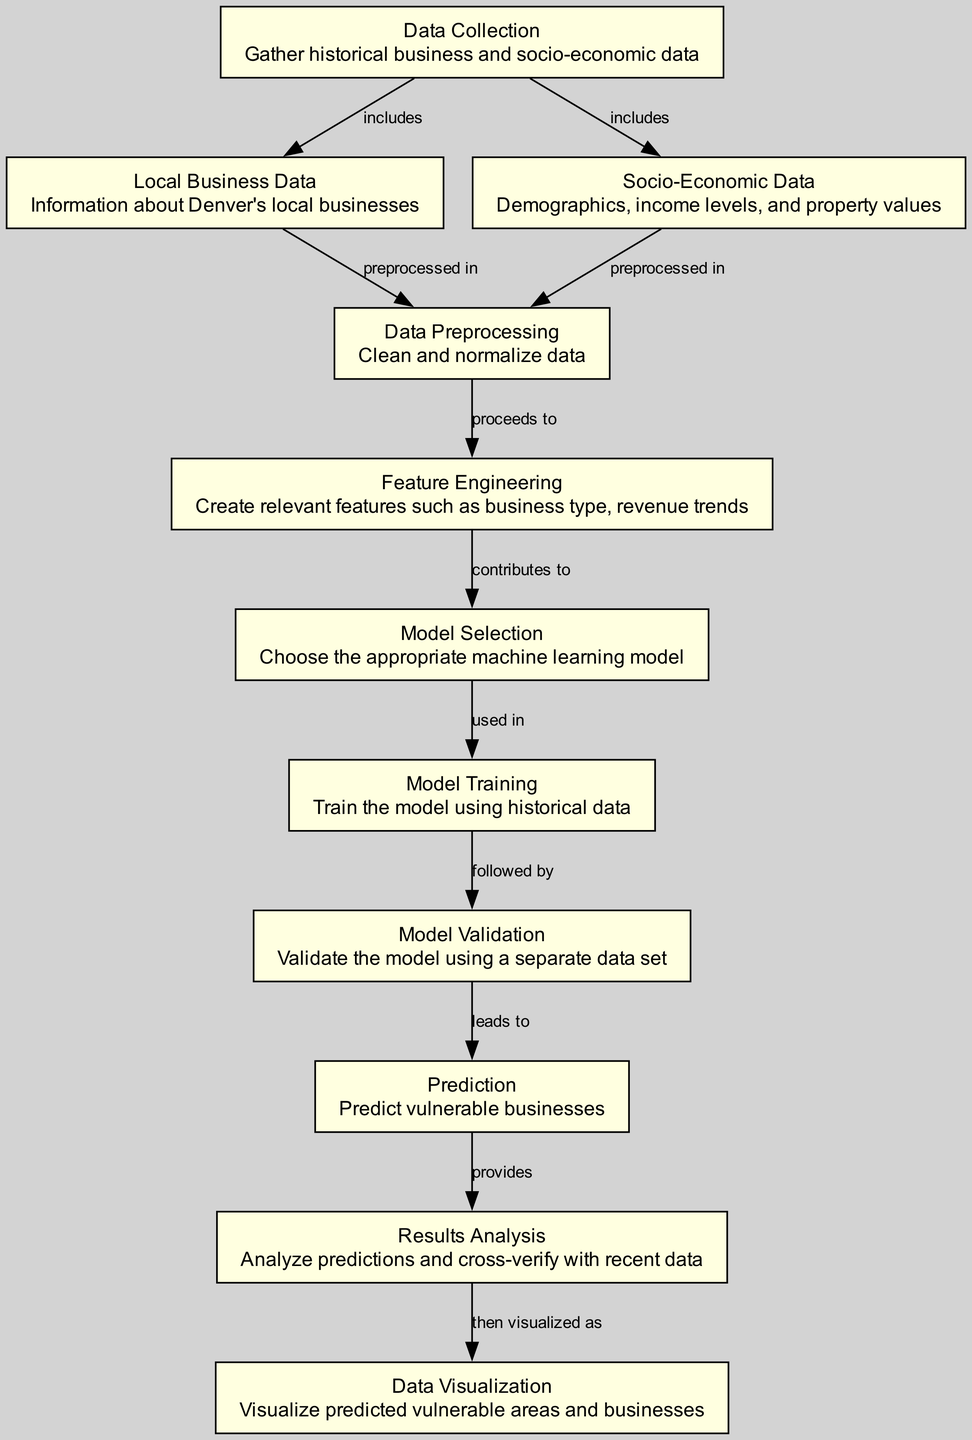What is the first step in the machine learning process? According to the diagram, the first step is "Data Collection," which involves gathering historical business and socio-economic data.
Answer: Data Collection How many nodes are present in the diagram? Counting the nodes listed in the diagram, there are eleven distinct nodes representing various steps in the machine learning process.
Answer: Eleven What type of data is included in data collection? The data collection includes "Local Business Data" and "Socio-Economic Data," reflecting the types of information gathered for analysis.
Answer: Local Business Data and Socio-Economic Data What follows after data preprocessing? After "Data Preprocessing," the next step is "Feature Engineering," where relevant features are created for the model.
Answer: Feature Engineering Which process leads to validation? The process that leads to "Validation" is "Model Training," indicating that the model must be trained before it can be validated.
Answer: Model Training What is the relationship between prediction and results analysis? The relationship is that "Prediction" provides input for "Results Analysis," which involves analyzing the predictions made by the model.
Answer: Provides Which node involves visualizing data? The node that involves visualizing data is "Data Visualization," where predicted vulnerable areas and businesses are visualized for better understanding.
Answer: Data Visualization How many edges connect the nodes in this diagram? By examining the edges connecting the nodes in the diagram, there are ten edges indicating the relationships and flow between different processes.
Answer: Ten What is the purpose of "Feature Engineering"? The purpose of "Feature Engineering" is to create relevant features that can enhance the performance of the machine learning model, such as business type and revenue trends.
Answer: Create relevant features What is the last step in the machine learning process? The last step in the process described by the diagram is "Data Visualization," which is where the results are visually represented to convey findings.
Answer: Data Visualization 